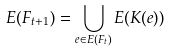Convert formula to latex. <formula><loc_0><loc_0><loc_500><loc_500>E ( F _ { t + 1 } ) = \bigcup _ { e \in E ( F _ { t } ) } E ( K ( e ) )</formula> 